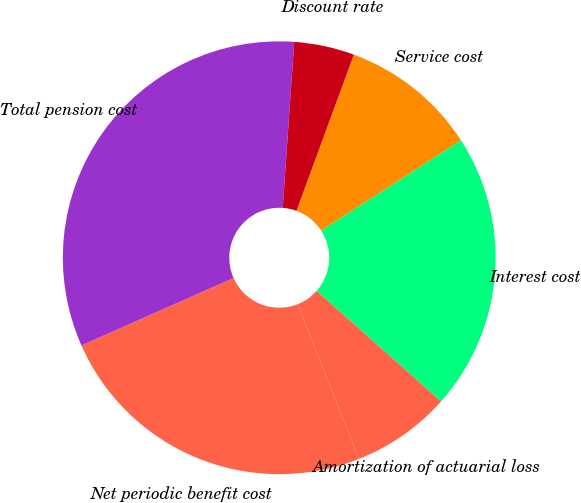<chart> <loc_0><loc_0><loc_500><loc_500><pie_chart><fcel>Service cost<fcel>Interest cost<fcel>Amortization of actuarial loss<fcel>Net periodic benefit cost<fcel>Total pension cost<fcel>Discount rate<nl><fcel>10.27%<fcel>20.68%<fcel>7.44%<fcel>24.36%<fcel>32.74%<fcel>4.5%<nl></chart> 